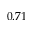Convert formula to latex. <formula><loc_0><loc_0><loc_500><loc_500>0 . 7 1</formula> 